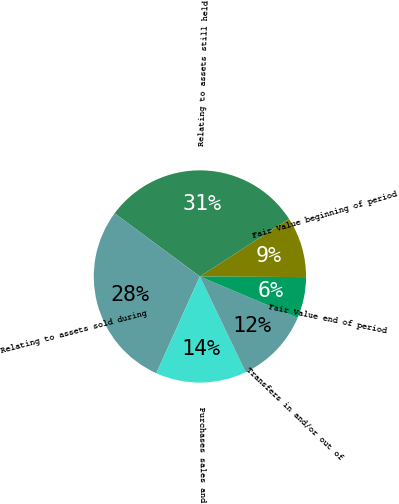Convert chart to OTSL. <chart><loc_0><loc_0><loc_500><loc_500><pie_chart><fcel>Fair Value beginning of period<fcel>Relating to assets still held<fcel>Relating to assets sold during<fcel>Purchases sales and<fcel>Transfers in and/or out of<fcel>Fair Value end of period<nl><fcel>9.23%<fcel>30.72%<fcel>28.41%<fcel>13.84%<fcel>11.53%<fcel>6.27%<nl></chart> 